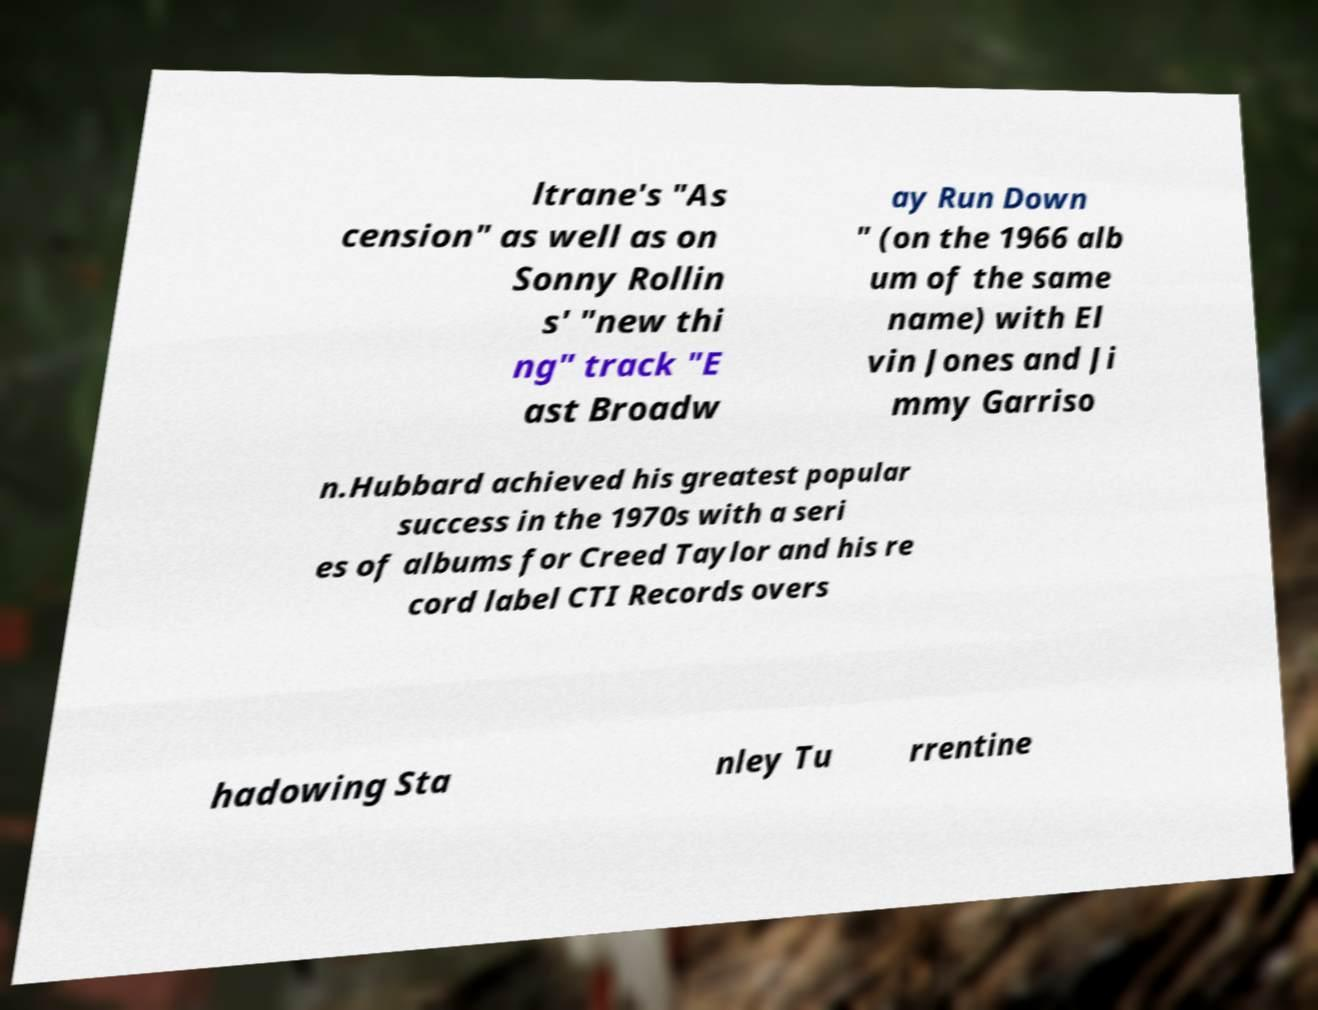Please read and relay the text visible in this image. What does it say? ltrane's "As cension" as well as on Sonny Rollin s' "new thi ng" track "E ast Broadw ay Run Down " (on the 1966 alb um of the same name) with El vin Jones and Ji mmy Garriso n.Hubbard achieved his greatest popular success in the 1970s with a seri es of albums for Creed Taylor and his re cord label CTI Records overs hadowing Sta nley Tu rrentine 